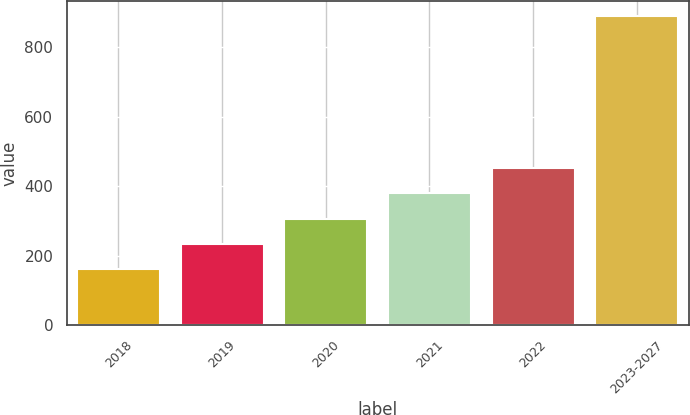Convert chart. <chart><loc_0><loc_0><loc_500><loc_500><bar_chart><fcel>2018<fcel>2019<fcel>2020<fcel>2021<fcel>2022<fcel>2023-2027<nl><fcel>161<fcel>233.7<fcel>306.4<fcel>379.1<fcel>451.8<fcel>888<nl></chart> 